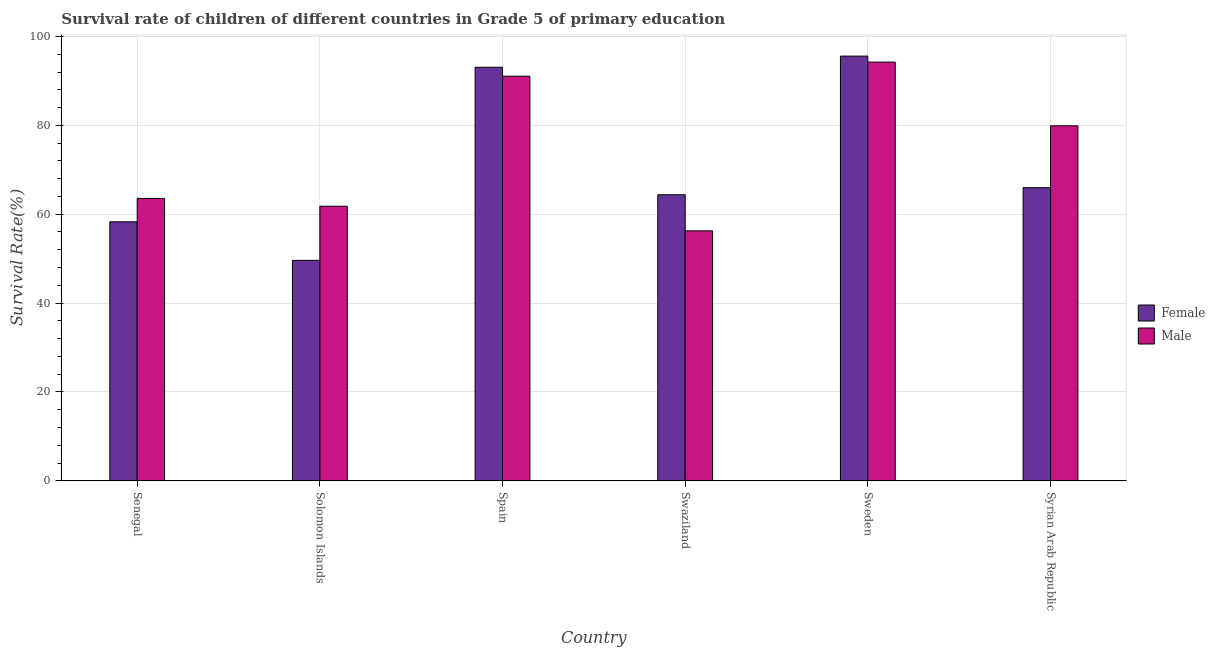How many groups of bars are there?
Make the answer very short. 6. How many bars are there on the 5th tick from the left?
Make the answer very short. 2. What is the label of the 6th group of bars from the left?
Offer a terse response. Syrian Arab Republic. What is the survival rate of female students in primary education in Sweden?
Provide a short and direct response. 95.58. Across all countries, what is the maximum survival rate of male students in primary education?
Give a very brief answer. 94.23. Across all countries, what is the minimum survival rate of female students in primary education?
Offer a terse response. 49.62. In which country was the survival rate of female students in primary education maximum?
Keep it short and to the point. Sweden. In which country was the survival rate of female students in primary education minimum?
Offer a very short reply. Solomon Islands. What is the total survival rate of male students in primary education in the graph?
Provide a succinct answer. 446.79. What is the difference between the survival rate of male students in primary education in Spain and that in Swaziland?
Provide a succinct answer. 34.81. What is the difference between the survival rate of male students in primary education in Swaziland and the survival rate of female students in primary education in Spain?
Provide a short and direct response. -36.81. What is the average survival rate of female students in primary education per country?
Offer a very short reply. 71.15. What is the difference between the survival rate of male students in primary education and survival rate of female students in primary education in Swaziland?
Ensure brevity in your answer.  -8.12. What is the ratio of the survival rate of male students in primary education in Spain to that in Swaziland?
Keep it short and to the point. 1.62. What is the difference between the highest and the second highest survival rate of female students in primary education?
Give a very brief answer. 2.51. What is the difference between the highest and the lowest survival rate of female students in primary education?
Your answer should be very brief. 45.97. In how many countries, is the survival rate of male students in primary education greater than the average survival rate of male students in primary education taken over all countries?
Offer a very short reply. 3. What does the 2nd bar from the right in Spain represents?
Your answer should be compact. Female. How many bars are there?
Offer a very short reply. 12. How many countries are there in the graph?
Your answer should be compact. 6. Does the graph contain any zero values?
Your response must be concise. No. Does the graph contain grids?
Provide a succinct answer. Yes. How are the legend labels stacked?
Ensure brevity in your answer.  Vertical. What is the title of the graph?
Your response must be concise. Survival rate of children of different countries in Grade 5 of primary education. What is the label or title of the X-axis?
Give a very brief answer. Country. What is the label or title of the Y-axis?
Offer a very short reply. Survival Rate(%). What is the Survival Rate(%) in Female in Senegal?
Keep it short and to the point. 58.29. What is the Survival Rate(%) of Male in Senegal?
Ensure brevity in your answer.  63.55. What is the Survival Rate(%) in Female in Solomon Islands?
Your answer should be very brief. 49.62. What is the Survival Rate(%) of Male in Solomon Islands?
Keep it short and to the point. 61.79. What is the Survival Rate(%) in Female in Spain?
Offer a terse response. 93.07. What is the Survival Rate(%) of Male in Spain?
Offer a very short reply. 91.06. What is the Survival Rate(%) of Female in Swaziland?
Make the answer very short. 64.38. What is the Survival Rate(%) of Male in Swaziland?
Give a very brief answer. 56.26. What is the Survival Rate(%) of Female in Sweden?
Give a very brief answer. 95.58. What is the Survival Rate(%) in Male in Sweden?
Your answer should be very brief. 94.23. What is the Survival Rate(%) of Female in Syrian Arab Republic?
Provide a succinct answer. 65.98. What is the Survival Rate(%) of Male in Syrian Arab Republic?
Provide a succinct answer. 79.9. Across all countries, what is the maximum Survival Rate(%) in Female?
Make the answer very short. 95.58. Across all countries, what is the maximum Survival Rate(%) of Male?
Make the answer very short. 94.23. Across all countries, what is the minimum Survival Rate(%) of Female?
Provide a succinct answer. 49.62. Across all countries, what is the minimum Survival Rate(%) of Male?
Provide a succinct answer. 56.26. What is the total Survival Rate(%) of Female in the graph?
Your answer should be compact. 426.92. What is the total Survival Rate(%) in Male in the graph?
Provide a succinct answer. 446.79. What is the difference between the Survival Rate(%) of Female in Senegal and that in Solomon Islands?
Ensure brevity in your answer.  8.67. What is the difference between the Survival Rate(%) of Male in Senegal and that in Solomon Islands?
Make the answer very short. 1.75. What is the difference between the Survival Rate(%) of Female in Senegal and that in Spain?
Offer a terse response. -34.78. What is the difference between the Survival Rate(%) in Male in Senegal and that in Spain?
Keep it short and to the point. -27.52. What is the difference between the Survival Rate(%) of Female in Senegal and that in Swaziland?
Offer a very short reply. -6.09. What is the difference between the Survival Rate(%) in Male in Senegal and that in Swaziland?
Your answer should be very brief. 7.29. What is the difference between the Survival Rate(%) of Female in Senegal and that in Sweden?
Provide a succinct answer. -37.29. What is the difference between the Survival Rate(%) of Male in Senegal and that in Sweden?
Your answer should be compact. -30.68. What is the difference between the Survival Rate(%) of Female in Senegal and that in Syrian Arab Republic?
Give a very brief answer. -7.68. What is the difference between the Survival Rate(%) in Male in Senegal and that in Syrian Arab Republic?
Offer a very short reply. -16.35. What is the difference between the Survival Rate(%) of Female in Solomon Islands and that in Spain?
Offer a terse response. -43.45. What is the difference between the Survival Rate(%) of Male in Solomon Islands and that in Spain?
Ensure brevity in your answer.  -29.27. What is the difference between the Survival Rate(%) of Female in Solomon Islands and that in Swaziland?
Your answer should be compact. -14.76. What is the difference between the Survival Rate(%) of Male in Solomon Islands and that in Swaziland?
Keep it short and to the point. 5.54. What is the difference between the Survival Rate(%) in Female in Solomon Islands and that in Sweden?
Give a very brief answer. -45.97. What is the difference between the Survival Rate(%) of Male in Solomon Islands and that in Sweden?
Offer a very short reply. -32.44. What is the difference between the Survival Rate(%) in Female in Solomon Islands and that in Syrian Arab Republic?
Provide a succinct answer. -16.36. What is the difference between the Survival Rate(%) of Male in Solomon Islands and that in Syrian Arab Republic?
Your answer should be compact. -18.1. What is the difference between the Survival Rate(%) of Female in Spain and that in Swaziland?
Your response must be concise. 28.69. What is the difference between the Survival Rate(%) in Male in Spain and that in Swaziland?
Offer a very short reply. 34.81. What is the difference between the Survival Rate(%) in Female in Spain and that in Sweden?
Your answer should be very brief. -2.51. What is the difference between the Survival Rate(%) in Male in Spain and that in Sweden?
Your response must be concise. -3.17. What is the difference between the Survival Rate(%) of Female in Spain and that in Syrian Arab Republic?
Keep it short and to the point. 27.1. What is the difference between the Survival Rate(%) in Male in Spain and that in Syrian Arab Republic?
Give a very brief answer. 11.17. What is the difference between the Survival Rate(%) of Female in Swaziland and that in Sweden?
Keep it short and to the point. -31.2. What is the difference between the Survival Rate(%) in Male in Swaziland and that in Sweden?
Offer a very short reply. -37.97. What is the difference between the Survival Rate(%) of Female in Swaziland and that in Syrian Arab Republic?
Offer a terse response. -1.6. What is the difference between the Survival Rate(%) of Male in Swaziland and that in Syrian Arab Republic?
Make the answer very short. -23.64. What is the difference between the Survival Rate(%) of Female in Sweden and that in Syrian Arab Republic?
Make the answer very short. 29.61. What is the difference between the Survival Rate(%) in Male in Sweden and that in Syrian Arab Republic?
Keep it short and to the point. 14.33. What is the difference between the Survival Rate(%) of Female in Senegal and the Survival Rate(%) of Male in Solomon Islands?
Your answer should be very brief. -3.5. What is the difference between the Survival Rate(%) of Female in Senegal and the Survival Rate(%) of Male in Spain?
Offer a terse response. -32.77. What is the difference between the Survival Rate(%) in Female in Senegal and the Survival Rate(%) in Male in Swaziland?
Ensure brevity in your answer.  2.03. What is the difference between the Survival Rate(%) in Female in Senegal and the Survival Rate(%) in Male in Sweden?
Ensure brevity in your answer.  -35.94. What is the difference between the Survival Rate(%) of Female in Senegal and the Survival Rate(%) of Male in Syrian Arab Republic?
Make the answer very short. -21.6. What is the difference between the Survival Rate(%) of Female in Solomon Islands and the Survival Rate(%) of Male in Spain?
Provide a short and direct response. -41.45. What is the difference between the Survival Rate(%) of Female in Solomon Islands and the Survival Rate(%) of Male in Swaziland?
Give a very brief answer. -6.64. What is the difference between the Survival Rate(%) in Female in Solomon Islands and the Survival Rate(%) in Male in Sweden?
Offer a terse response. -44.61. What is the difference between the Survival Rate(%) of Female in Solomon Islands and the Survival Rate(%) of Male in Syrian Arab Republic?
Provide a succinct answer. -30.28. What is the difference between the Survival Rate(%) of Female in Spain and the Survival Rate(%) of Male in Swaziland?
Provide a short and direct response. 36.81. What is the difference between the Survival Rate(%) in Female in Spain and the Survival Rate(%) in Male in Sweden?
Offer a very short reply. -1.16. What is the difference between the Survival Rate(%) of Female in Spain and the Survival Rate(%) of Male in Syrian Arab Republic?
Offer a very short reply. 13.17. What is the difference between the Survival Rate(%) of Female in Swaziland and the Survival Rate(%) of Male in Sweden?
Provide a short and direct response. -29.85. What is the difference between the Survival Rate(%) of Female in Swaziland and the Survival Rate(%) of Male in Syrian Arab Republic?
Provide a succinct answer. -15.52. What is the difference between the Survival Rate(%) in Female in Sweden and the Survival Rate(%) in Male in Syrian Arab Republic?
Ensure brevity in your answer.  15.69. What is the average Survival Rate(%) in Female per country?
Offer a terse response. 71.15. What is the average Survival Rate(%) in Male per country?
Your answer should be compact. 74.46. What is the difference between the Survival Rate(%) of Female and Survival Rate(%) of Male in Senegal?
Provide a short and direct response. -5.25. What is the difference between the Survival Rate(%) of Female and Survival Rate(%) of Male in Solomon Islands?
Give a very brief answer. -12.18. What is the difference between the Survival Rate(%) of Female and Survival Rate(%) of Male in Spain?
Give a very brief answer. 2.01. What is the difference between the Survival Rate(%) in Female and Survival Rate(%) in Male in Swaziland?
Your answer should be compact. 8.12. What is the difference between the Survival Rate(%) of Female and Survival Rate(%) of Male in Sweden?
Ensure brevity in your answer.  1.35. What is the difference between the Survival Rate(%) in Female and Survival Rate(%) in Male in Syrian Arab Republic?
Your response must be concise. -13.92. What is the ratio of the Survival Rate(%) of Female in Senegal to that in Solomon Islands?
Provide a succinct answer. 1.17. What is the ratio of the Survival Rate(%) of Male in Senegal to that in Solomon Islands?
Give a very brief answer. 1.03. What is the ratio of the Survival Rate(%) of Female in Senegal to that in Spain?
Make the answer very short. 0.63. What is the ratio of the Survival Rate(%) in Male in Senegal to that in Spain?
Your response must be concise. 0.7. What is the ratio of the Survival Rate(%) of Female in Senegal to that in Swaziland?
Provide a succinct answer. 0.91. What is the ratio of the Survival Rate(%) of Male in Senegal to that in Swaziland?
Your answer should be compact. 1.13. What is the ratio of the Survival Rate(%) in Female in Senegal to that in Sweden?
Offer a terse response. 0.61. What is the ratio of the Survival Rate(%) of Male in Senegal to that in Sweden?
Your response must be concise. 0.67. What is the ratio of the Survival Rate(%) in Female in Senegal to that in Syrian Arab Republic?
Offer a terse response. 0.88. What is the ratio of the Survival Rate(%) of Male in Senegal to that in Syrian Arab Republic?
Offer a very short reply. 0.8. What is the ratio of the Survival Rate(%) in Female in Solomon Islands to that in Spain?
Your response must be concise. 0.53. What is the ratio of the Survival Rate(%) in Male in Solomon Islands to that in Spain?
Give a very brief answer. 0.68. What is the ratio of the Survival Rate(%) in Female in Solomon Islands to that in Swaziland?
Your response must be concise. 0.77. What is the ratio of the Survival Rate(%) in Male in Solomon Islands to that in Swaziland?
Provide a short and direct response. 1.1. What is the ratio of the Survival Rate(%) of Female in Solomon Islands to that in Sweden?
Make the answer very short. 0.52. What is the ratio of the Survival Rate(%) in Male in Solomon Islands to that in Sweden?
Provide a succinct answer. 0.66. What is the ratio of the Survival Rate(%) in Female in Solomon Islands to that in Syrian Arab Republic?
Offer a very short reply. 0.75. What is the ratio of the Survival Rate(%) in Male in Solomon Islands to that in Syrian Arab Republic?
Your answer should be very brief. 0.77. What is the ratio of the Survival Rate(%) of Female in Spain to that in Swaziland?
Make the answer very short. 1.45. What is the ratio of the Survival Rate(%) in Male in Spain to that in Swaziland?
Provide a succinct answer. 1.62. What is the ratio of the Survival Rate(%) in Female in Spain to that in Sweden?
Provide a succinct answer. 0.97. What is the ratio of the Survival Rate(%) in Male in Spain to that in Sweden?
Offer a very short reply. 0.97. What is the ratio of the Survival Rate(%) in Female in Spain to that in Syrian Arab Republic?
Offer a very short reply. 1.41. What is the ratio of the Survival Rate(%) in Male in Spain to that in Syrian Arab Republic?
Your answer should be compact. 1.14. What is the ratio of the Survival Rate(%) of Female in Swaziland to that in Sweden?
Your answer should be very brief. 0.67. What is the ratio of the Survival Rate(%) of Male in Swaziland to that in Sweden?
Your answer should be very brief. 0.6. What is the ratio of the Survival Rate(%) of Female in Swaziland to that in Syrian Arab Republic?
Provide a succinct answer. 0.98. What is the ratio of the Survival Rate(%) in Male in Swaziland to that in Syrian Arab Republic?
Offer a very short reply. 0.7. What is the ratio of the Survival Rate(%) of Female in Sweden to that in Syrian Arab Republic?
Provide a short and direct response. 1.45. What is the ratio of the Survival Rate(%) of Male in Sweden to that in Syrian Arab Republic?
Keep it short and to the point. 1.18. What is the difference between the highest and the second highest Survival Rate(%) of Female?
Offer a very short reply. 2.51. What is the difference between the highest and the second highest Survival Rate(%) of Male?
Offer a terse response. 3.17. What is the difference between the highest and the lowest Survival Rate(%) in Female?
Offer a very short reply. 45.97. What is the difference between the highest and the lowest Survival Rate(%) of Male?
Give a very brief answer. 37.97. 